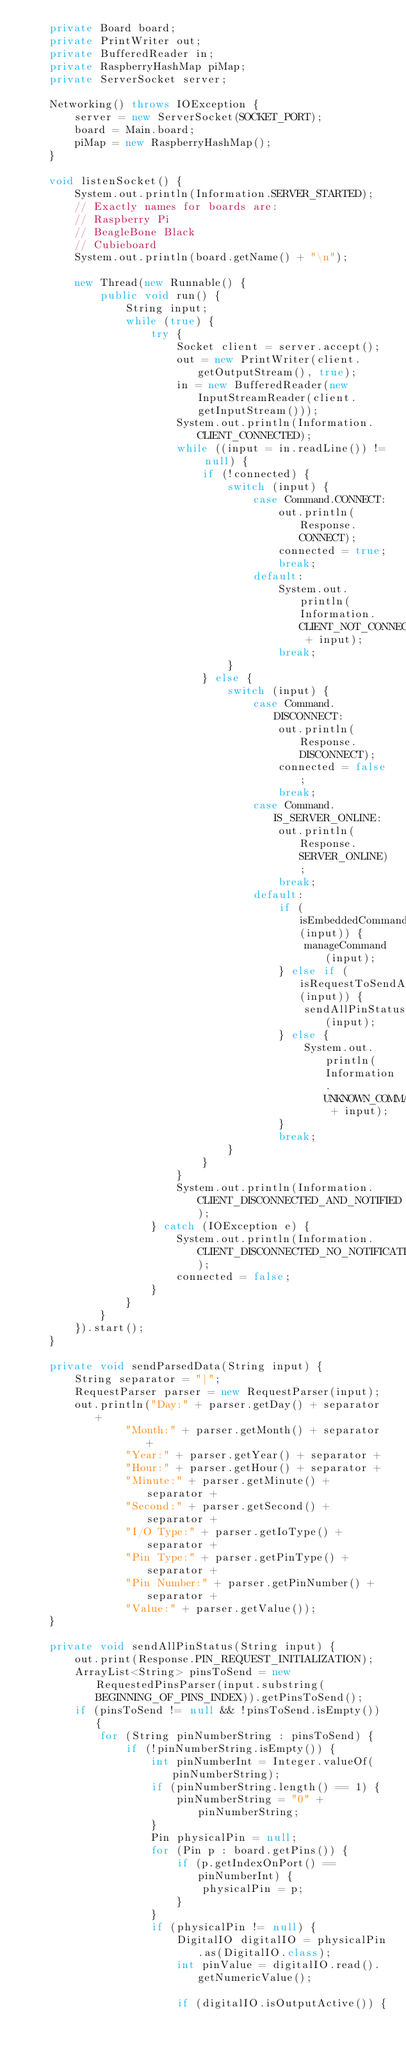<code> <loc_0><loc_0><loc_500><loc_500><_Java_>    private Board board;
    private PrintWriter out;
    private BufferedReader in;
    private RaspberryHashMap piMap;
    private ServerSocket server;

    Networking() throws IOException {
        server = new ServerSocket(SOCKET_PORT);
        board = Main.board;
        piMap = new RaspberryHashMap();
    }

    void listenSocket() {
        System.out.println(Information.SERVER_STARTED);
        // Exactly names for boards are:
        // Raspberry Pi
        // BeagleBone Black
        // Cubieboard
        System.out.println(board.getName() + "\n");

        new Thread(new Runnable() {
            public void run() {
                String input;
                while (true) {
                    try {
                        Socket client = server.accept();
                        out = new PrintWriter(client.getOutputStream(), true);
                        in = new BufferedReader(new InputStreamReader(client.getInputStream()));
                        System.out.println(Information.CLIENT_CONNECTED);
                        while ((input = in.readLine()) != null) {
                            if (!connected) {
                                switch (input) {
                                    case Command.CONNECT:
                                        out.println(Response.CONNECT);
                                        connected = true;
                                        break;
                                    default:
                                        System.out.println(Information.CLIENT_NOT_CONNECTED + input);
                                        break;
                                }
                            } else {
                                switch (input) {
                                    case Command.DISCONNECT:
                                        out.println(Response.DISCONNECT);
                                        connected = false;
                                        break;
                                    case Command.IS_SERVER_ONLINE:
                                        out.println(Response.SERVER_ONLINE);
                                        break;
                                    default:
                                        if (isEmbeddedCommand(input)) {
                                            manageCommand(input);
                                        } else if (isRequestToSendAll(input)) {
                                            sendAllPinStatus(input);
                                        } else {
                                            System.out.println(Information.UNKNOWN_COMMAND + input);
                                        }
                                        break;
                                }
                            }
                        }
                        System.out.println(Information.CLIENT_DISCONNECTED_AND_NOTIFIED);
                    } catch (IOException e) {
                        System.out.println(Information.CLIENT_DISCONNECTED_NO_NOTIFICATION);
                        connected = false;
                    }
                }
            }
        }).start();
    }

    private void sendParsedData(String input) {
        String separator = "|";
        RequestParser parser = new RequestParser(input);
        out.println("Day:" + parser.getDay() + separator +
                "Month:" + parser.getMonth() + separator +
                "Year:" + parser.getYear() + separator +
                "Hour:" + parser.getHour() + separator +
                "Minute:" + parser.getMinute() + separator +
                "Second:" + parser.getSecond() + separator +
                "I/O Type:" + parser.getIoType() + separator +
                "Pin Type:" + parser.getPinType() + separator +
                "Pin Number:" + parser.getPinNumber() + separator +
                "Value:" + parser.getValue());
    }

    private void sendAllPinStatus(String input) {
        out.print(Response.PIN_REQUEST_INITIALIZATION);
        ArrayList<String> pinsToSend = new RequestedPinsParser(input.substring(BEGINNING_OF_PINS_INDEX)).getPinsToSend();
        if (pinsToSend != null && !pinsToSend.isEmpty()) {
            for (String pinNumberString : pinsToSend) {
                if (!pinNumberString.isEmpty()) {
                    int pinNumberInt = Integer.valueOf(pinNumberString);
                    if (pinNumberString.length() == 1) {
                        pinNumberString = "0" + pinNumberString;
                    }
                    Pin physicalPin = null;
                    for (Pin p : board.getPins()) {
                        if (p.getIndexOnPort() == pinNumberInt) {
                            physicalPin = p;
                        }
                    }
                    if (physicalPin != null) {
                        DigitalIO digitalIO = physicalPin.as(DigitalIO.class);
                        int pinValue = digitalIO.read().getNumericValue();

                        if (digitalIO.isOutputActive()) {</code> 